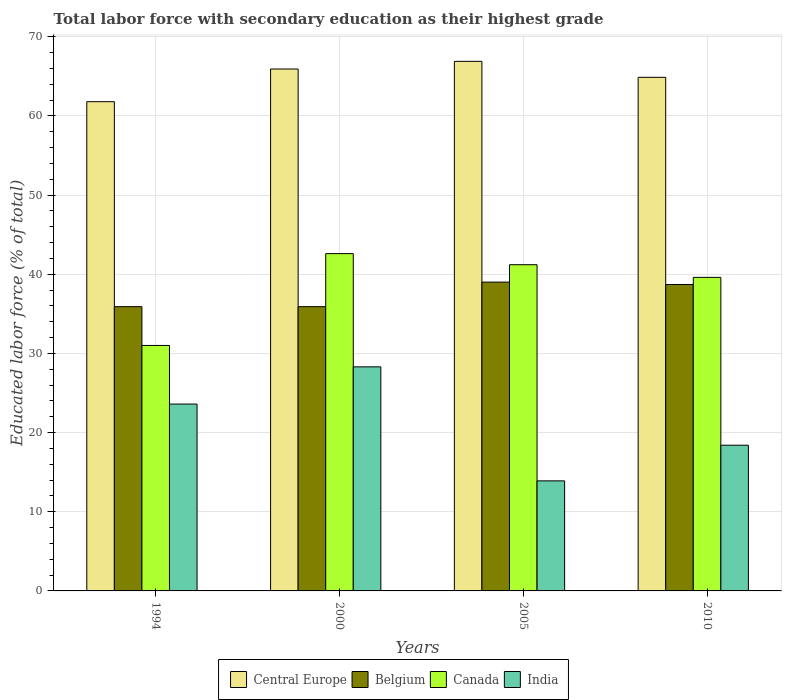How many different coloured bars are there?
Your answer should be very brief. 4. What is the label of the 4th group of bars from the left?
Your response must be concise. 2010. In how many cases, is the number of bars for a given year not equal to the number of legend labels?
Offer a very short reply. 0. What is the percentage of total labor force with primary education in Belgium in 2000?
Your response must be concise. 35.9. Across all years, what is the maximum percentage of total labor force with primary education in Canada?
Your answer should be compact. 42.6. Across all years, what is the minimum percentage of total labor force with primary education in India?
Give a very brief answer. 13.9. In which year was the percentage of total labor force with primary education in India maximum?
Your answer should be compact. 2000. What is the total percentage of total labor force with primary education in Canada in the graph?
Offer a very short reply. 154.4. What is the difference between the percentage of total labor force with primary education in Belgium in 1994 and that in 2010?
Give a very brief answer. -2.8. What is the difference between the percentage of total labor force with primary education in Central Europe in 2010 and the percentage of total labor force with primary education in India in 1994?
Provide a short and direct response. 41.27. What is the average percentage of total labor force with primary education in Canada per year?
Your answer should be very brief. 38.6. In the year 2000, what is the difference between the percentage of total labor force with primary education in Belgium and percentage of total labor force with primary education in Canada?
Give a very brief answer. -6.7. What is the ratio of the percentage of total labor force with primary education in India in 2005 to that in 2010?
Offer a very short reply. 0.76. Is the percentage of total labor force with primary education in Canada in 1994 less than that in 2005?
Ensure brevity in your answer.  Yes. What is the difference between the highest and the second highest percentage of total labor force with primary education in Canada?
Keep it short and to the point. 1.4. What is the difference between the highest and the lowest percentage of total labor force with primary education in Belgium?
Make the answer very short. 3.1. Is the sum of the percentage of total labor force with primary education in India in 2005 and 2010 greater than the maximum percentage of total labor force with primary education in Central Europe across all years?
Your response must be concise. No. Is it the case that in every year, the sum of the percentage of total labor force with primary education in Belgium and percentage of total labor force with primary education in India is greater than the sum of percentage of total labor force with primary education in Canada and percentage of total labor force with primary education in Central Europe?
Give a very brief answer. No. Is it the case that in every year, the sum of the percentage of total labor force with primary education in Central Europe and percentage of total labor force with primary education in Belgium is greater than the percentage of total labor force with primary education in Canada?
Give a very brief answer. Yes. How many years are there in the graph?
Offer a very short reply. 4. Are the values on the major ticks of Y-axis written in scientific E-notation?
Provide a short and direct response. No. Does the graph contain any zero values?
Give a very brief answer. No. How many legend labels are there?
Give a very brief answer. 4. What is the title of the graph?
Give a very brief answer. Total labor force with secondary education as their highest grade. What is the label or title of the X-axis?
Make the answer very short. Years. What is the label or title of the Y-axis?
Provide a short and direct response. Educated labor force (% of total). What is the Educated labor force (% of total) of Central Europe in 1994?
Your answer should be compact. 61.79. What is the Educated labor force (% of total) in Belgium in 1994?
Make the answer very short. 35.9. What is the Educated labor force (% of total) in Canada in 1994?
Ensure brevity in your answer.  31. What is the Educated labor force (% of total) in India in 1994?
Keep it short and to the point. 23.6. What is the Educated labor force (% of total) in Central Europe in 2000?
Ensure brevity in your answer.  65.91. What is the Educated labor force (% of total) of Belgium in 2000?
Give a very brief answer. 35.9. What is the Educated labor force (% of total) in Canada in 2000?
Offer a very short reply. 42.6. What is the Educated labor force (% of total) in India in 2000?
Offer a terse response. 28.3. What is the Educated labor force (% of total) of Central Europe in 2005?
Offer a terse response. 66.88. What is the Educated labor force (% of total) of Belgium in 2005?
Your answer should be very brief. 39. What is the Educated labor force (% of total) of Canada in 2005?
Provide a succinct answer. 41.2. What is the Educated labor force (% of total) in India in 2005?
Ensure brevity in your answer.  13.9. What is the Educated labor force (% of total) in Central Europe in 2010?
Keep it short and to the point. 64.87. What is the Educated labor force (% of total) in Belgium in 2010?
Your answer should be compact. 38.7. What is the Educated labor force (% of total) in Canada in 2010?
Your answer should be very brief. 39.6. What is the Educated labor force (% of total) in India in 2010?
Provide a succinct answer. 18.4. Across all years, what is the maximum Educated labor force (% of total) of Central Europe?
Your response must be concise. 66.88. Across all years, what is the maximum Educated labor force (% of total) in Canada?
Make the answer very short. 42.6. Across all years, what is the maximum Educated labor force (% of total) of India?
Give a very brief answer. 28.3. Across all years, what is the minimum Educated labor force (% of total) of Central Europe?
Offer a very short reply. 61.79. Across all years, what is the minimum Educated labor force (% of total) in Belgium?
Offer a very short reply. 35.9. Across all years, what is the minimum Educated labor force (% of total) in India?
Give a very brief answer. 13.9. What is the total Educated labor force (% of total) of Central Europe in the graph?
Your response must be concise. 259.45. What is the total Educated labor force (% of total) in Belgium in the graph?
Offer a very short reply. 149.5. What is the total Educated labor force (% of total) in Canada in the graph?
Offer a very short reply. 154.4. What is the total Educated labor force (% of total) in India in the graph?
Offer a very short reply. 84.2. What is the difference between the Educated labor force (% of total) of Central Europe in 1994 and that in 2000?
Provide a short and direct response. -4.13. What is the difference between the Educated labor force (% of total) in India in 1994 and that in 2000?
Ensure brevity in your answer.  -4.7. What is the difference between the Educated labor force (% of total) in Central Europe in 1994 and that in 2005?
Provide a short and direct response. -5.09. What is the difference between the Educated labor force (% of total) in India in 1994 and that in 2005?
Give a very brief answer. 9.7. What is the difference between the Educated labor force (% of total) in Central Europe in 1994 and that in 2010?
Your answer should be very brief. -3.08. What is the difference between the Educated labor force (% of total) of Central Europe in 2000 and that in 2005?
Offer a very short reply. -0.97. What is the difference between the Educated labor force (% of total) in Canada in 2000 and that in 2005?
Give a very brief answer. 1.4. What is the difference between the Educated labor force (% of total) in India in 2000 and that in 2005?
Offer a very short reply. 14.4. What is the difference between the Educated labor force (% of total) of Central Europe in 2000 and that in 2010?
Keep it short and to the point. 1.05. What is the difference between the Educated labor force (% of total) of Belgium in 2000 and that in 2010?
Your response must be concise. -2.8. What is the difference between the Educated labor force (% of total) of Central Europe in 2005 and that in 2010?
Your answer should be very brief. 2.02. What is the difference between the Educated labor force (% of total) in Belgium in 2005 and that in 2010?
Make the answer very short. 0.3. What is the difference between the Educated labor force (% of total) in Canada in 2005 and that in 2010?
Give a very brief answer. 1.6. What is the difference between the Educated labor force (% of total) of India in 2005 and that in 2010?
Make the answer very short. -4.5. What is the difference between the Educated labor force (% of total) in Central Europe in 1994 and the Educated labor force (% of total) in Belgium in 2000?
Give a very brief answer. 25.89. What is the difference between the Educated labor force (% of total) of Central Europe in 1994 and the Educated labor force (% of total) of Canada in 2000?
Provide a short and direct response. 19.19. What is the difference between the Educated labor force (% of total) of Central Europe in 1994 and the Educated labor force (% of total) of India in 2000?
Give a very brief answer. 33.49. What is the difference between the Educated labor force (% of total) of Central Europe in 1994 and the Educated labor force (% of total) of Belgium in 2005?
Give a very brief answer. 22.79. What is the difference between the Educated labor force (% of total) in Central Europe in 1994 and the Educated labor force (% of total) in Canada in 2005?
Your answer should be compact. 20.59. What is the difference between the Educated labor force (% of total) in Central Europe in 1994 and the Educated labor force (% of total) in India in 2005?
Your answer should be compact. 47.89. What is the difference between the Educated labor force (% of total) of Belgium in 1994 and the Educated labor force (% of total) of India in 2005?
Offer a terse response. 22. What is the difference between the Educated labor force (% of total) of Canada in 1994 and the Educated labor force (% of total) of India in 2005?
Your answer should be very brief. 17.1. What is the difference between the Educated labor force (% of total) of Central Europe in 1994 and the Educated labor force (% of total) of Belgium in 2010?
Ensure brevity in your answer.  23.09. What is the difference between the Educated labor force (% of total) in Central Europe in 1994 and the Educated labor force (% of total) in Canada in 2010?
Ensure brevity in your answer.  22.19. What is the difference between the Educated labor force (% of total) in Central Europe in 1994 and the Educated labor force (% of total) in India in 2010?
Make the answer very short. 43.39. What is the difference between the Educated labor force (% of total) of Canada in 1994 and the Educated labor force (% of total) of India in 2010?
Give a very brief answer. 12.6. What is the difference between the Educated labor force (% of total) of Central Europe in 2000 and the Educated labor force (% of total) of Belgium in 2005?
Your answer should be compact. 26.91. What is the difference between the Educated labor force (% of total) of Central Europe in 2000 and the Educated labor force (% of total) of Canada in 2005?
Provide a succinct answer. 24.71. What is the difference between the Educated labor force (% of total) in Central Europe in 2000 and the Educated labor force (% of total) in India in 2005?
Keep it short and to the point. 52.02. What is the difference between the Educated labor force (% of total) in Belgium in 2000 and the Educated labor force (% of total) in Canada in 2005?
Provide a short and direct response. -5.3. What is the difference between the Educated labor force (% of total) of Canada in 2000 and the Educated labor force (% of total) of India in 2005?
Ensure brevity in your answer.  28.7. What is the difference between the Educated labor force (% of total) in Central Europe in 2000 and the Educated labor force (% of total) in Belgium in 2010?
Provide a succinct answer. 27.21. What is the difference between the Educated labor force (% of total) of Central Europe in 2000 and the Educated labor force (% of total) of Canada in 2010?
Keep it short and to the point. 26.32. What is the difference between the Educated labor force (% of total) of Central Europe in 2000 and the Educated labor force (% of total) of India in 2010?
Provide a short and direct response. 47.52. What is the difference between the Educated labor force (% of total) of Belgium in 2000 and the Educated labor force (% of total) of Canada in 2010?
Your answer should be compact. -3.7. What is the difference between the Educated labor force (% of total) of Canada in 2000 and the Educated labor force (% of total) of India in 2010?
Offer a terse response. 24.2. What is the difference between the Educated labor force (% of total) in Central Europe in 2005 and the Educated labor force (% of total) in Belgium in 2010?
Keep it short and to the point. 28.18. What is the difference between the Educated labor force (% of total) of Central Europe in 2005 and the Educated labor force (% of total) of Canada in 2010?
Make the answer very short. 27.28. What is the difference between the Educated labor force (% of total) in Central Europe in 2005 and the Educated labor force (% of total) in India in 2010?
Offer a very short reply. 48.48. What is the difference between the Educated labor force (% of total) in Belgium in 2005 and the Educated labor force (% of total) in India in 2010?
Provide a succinct answer. 20.6. What is the difference between the Educated labor force (% of total) in Canada in 2005 and the Educated labor force (% of total) in India in 2010?
Keep it short and to the point. 22.8. What is the average Educated labor force (% of total) of Central Europe per year?
Ensure brevity in your answer.  64.86. What is the average Educated labor force (% of total) in Belgium per year?
Provide a short and direct response. 37.38. What is the average Educated labor force (% of total) in Canada per year?
Provide a succinct answer. 38.6. What is the average Educated labor force (% of total) in India per year?
Provide a short and direct response. 21.05. In the year 1994, what is the difference between the Educated labor force (% of total) in Central Europe and Educated labor force (% of total) in Belgium?
Give a very brief answer. 25.89. In the year 1994, what is the difference between the Educated labor force (% of total) in Central Europe and Educated labor force (% of total) in Canada?
Provide a short and direct response. 30.79. In the year 1994, what is the difference between the Educated labor force (% of total) in Central Europe and Educated labor force (% of total) in India?
Make the answer very short. 38.19. In the year 1994, what is the difference between the Educated labor force (% of total) in Belgium and Educated labor force (% of total) in Canada?
Your answer should be very brief. 4.9. In the year 1994, what is the difference between the Educated labor force (% of total) in Belgium and Educated labor force (% of total) in India?
Your answer should be very brief. 12.3. In the year 2000, what is the difference between the Educated labor force (% of total) in Central Europe and Educated labor force (% of total) in Belgium?
Ensure brevity in your answer.  30.02. In the year 2000, what is the difference between the Educated labor force (% of total) in Central Europe and Educated labor force (% of total) in Canada?
Your response must be concise. 23.32. In the year 2000, what is the difference between the Educated labor force (% of total) of Central Europe and Educated labor force (% of total) of India?
Offer a terse response. 37.62. In the year 2000, what is the difference between the Educated labor force (% of total) of Belgium and Educated labor force (% of total) of India?
Offer a very short reply. 7.6. In the year 2000, what is the difference between the Educated labor force (% of total) in Canada and Educated labor force (% of total) in India?
Offer a terse response. 14.3. In the year 2005, what is the difference between the Educated labor force (% of total) in Central Europe and Educated labor force (% of total) in Belgium?
Offer a very short reply. 27.88. In the year 2005, what is the difference between the Educated labor force (% of total) of Central Europe and Educated labor force (% of total) of Canada?
Your response must be concise. 25.68. In the year 2005, what is the difference between the Educated labor force (% of total) in Central Europe and Educated labor force (% of total) in India?
Your answer should be compact. 52.98. In the year 2005, what is the difference between the Educated labor force (% of total) in Belgium and Educated labor force (% of total) in India?
Your answer should be very brief. 25.1. In the year 2005, what is the difference between the Educated labor force (% of total) in Canada and Educated labor force (% of total) in India?
Offer a terse response. 27.3. In the year 2010, what is the difference between the Educated labor force (% of total) in Central Europe and Educated labor force (% of total) in Belgium?
Your answer should be very brief. 26.17. In the year 2010, what is the difference between the Educated labor force (% of total) in Central Europe and Educated labor force (% of total) in Canada?
Your answer should be compact. 25.27. In the year 2010, what is the difference between the Educated labor force (% of total) in Central Europe and Educated labor force (% of total) in India?
Make the answer very short. 46.47. In the year 2010, what is the difference between the Educated labor force (% of total) in Belgium and Educated labor force (% of total) in India?
Offer a very short reply. 20.3. In the year 2010, what is the difference between the Educated labor force (% of total) of Canada and Educated labor force (% of total) of India?
Keep it short and to the point. 21.2. What is the ratio of the Educated labor force (% of total) in Central Europe in 1994 to that in 2000?
Make the answer very short. 0.94. What is the ratio of the Educated labor force (% of total) in Canada in 1994 to that in 2000?
Provide a succinct answer. 0.73. What is the ratio of the Educated labor force (% of total) of India in 1994 to that in 2000?
Your answer should be very brief. 0.83. What is the ratio of the Educated labor force (% of total) of Central Europe in 1994 to that in 2005?
Keep it short and to the point. 0.92. What is the ratio of the Educated labor force (% of total) in Belgium in 1994 to that in 2005?
Make the answer very short. 0.92. What is the ratio of the Educated labor force (% of total) in Canada in 1994 to that in 2005?
Your answer should be very brief. 0.75. What is the ratio of the Educated labor force (% of total) in India in 1994 to that in 2005?
Your response must be concise. 1.7. What is the ratio of the Educated labor force (% of total) of Central Europe in 1994 to that in 2010?
Offer a terse response. 0.95. What is the ratio of the Educated labor force (% of total) of Belgium in 1994 to that in 2010?
Make the answer very short. 0.93. What is the ratio of the Educated labor force (% of total) of Canada in 1994 to that in 2010?
Make the answer very short. 0.78. What is the ratio of the Educated labor force (% of total) in India in 1994 to that in 2010?
Offer a very short reply. 1.28. What is the ratio of the Educated labor force (% of total) of Central Europe in 2000 to that in 2005?
Ensure brevity in your answer.  0.99. What is the ratio of the Educated labor force (% of total) in Belgium in 2000 to that in 2005?
Give a very brief answer. 0.92. What is the ratio of the Educated labor force (% of total) in Canada in 2000 to that in 2005?
Make the answer very short. 1.03. What is the ratio of the Educated labor force (% of total) of India in 2000 to that in 2005?
Provide a succinct answer. 2.04. What is the ratio of the Educated labor force (% of total) of Central Europe in 2000 to that in 2010?
Keep it short and to the point. 1.02. What is the ratio of the Educated labor force (% of total) in Belgium in 2000 to that in 2010?
Your response must be concise. 0.93. What is the ratio of the Educated labor force (% of total) of Canada in 2000 to that in 2010?
Your response must be concise. 1.08. What is the ratio of the Educated labor force (% of total) in India in 2000 to that in 2010?
Your answer should be compact. 1.54. What is the ratio of the Educated labor force (% of total) in Central Europe in 2005 to that in 2010?
Keep it short and to the point. 1.03. What is the ratio of the Educated labor force (% of total) in Belgium in 2005 to that in 2010?
Provide a short and direct response. 1.01. What is the ratio of the Educated labor force (% of total) in Canada in 2005 to that in 2010?
Offer a terse response. 1.04. What is the ratio of the Educated labor force (% of total) of India in 2005 to that in 2010?
Give a very brief answer. 0.76. What is the difference between the highest and the second highest Educated labor force (% of total) in Central Europe?
Make the answer very short. 0.97. What is the difference between the highest and the second highest Educated labor force (% of total) of Belgium?
Provide a succinct answer. 0.3. What is the difference between the highest and the lowest Educated labor force (% of total) in Central Europe?
Offer a very short reply. 5.09. What is the difference between the highest and the lowest Educated labor force (% of total) of Belgium?
Your answer should be very brief. 3.1. 